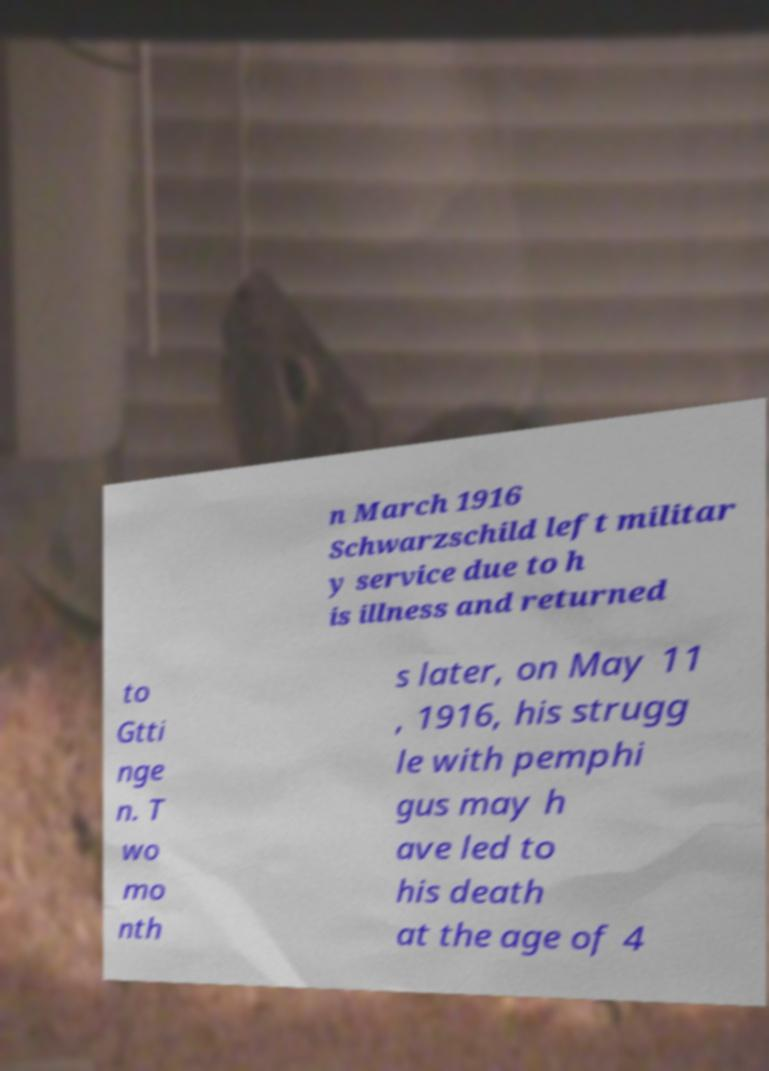What messages or text are displayed in this image? I need them in a readable, typed format. n March 1916 Schwarzschild left militar y service due to h is illness and returned to Gtti nge n. T wo mo nth s later, on May 11 , 1916, his strugg le with pemphi gus may h ave led to his death at the age of 4 